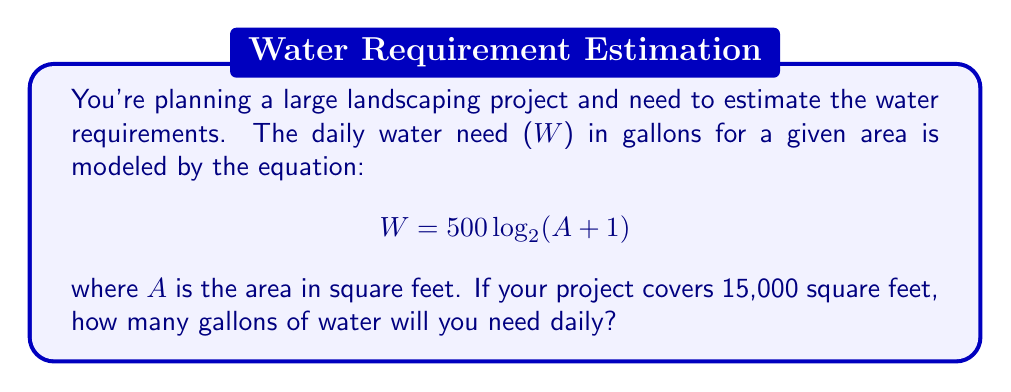Can you solve this math problem? Let's approach this step-by-step:

1) We're given the formula: $W = 500 \log_{2}(A + 1)$
   Where W is the daily water need in gallons and A is the area in square feet.

2) We know that A = 15,000 sq ft. Let's substitute this into our equation:

   $W = 500 \log_{2}(15,000 + 1)$

3) Simplify inside the parentheses:

   $W = 500 \log_{2}(15,001)$

4) Now, we need to calculate $\log_{2}(15,001)$. This isn't a simple calculation to do by hand, so we'd typically use a calculator or logarithm tables. Using a calculator:

   $\log_{2}(15,001) \approx 13.8723$

5) Now we can complete our calculation:

   $W = 500 * 13.8723$

6) Multiply:

   $W = 6,936.15$ gallons

7) Since we're dealing with water requirements, it makes sense to round to the nearest whole gallon:

   $W = 6,936$ gallons
Answer: 6,936 gallons 